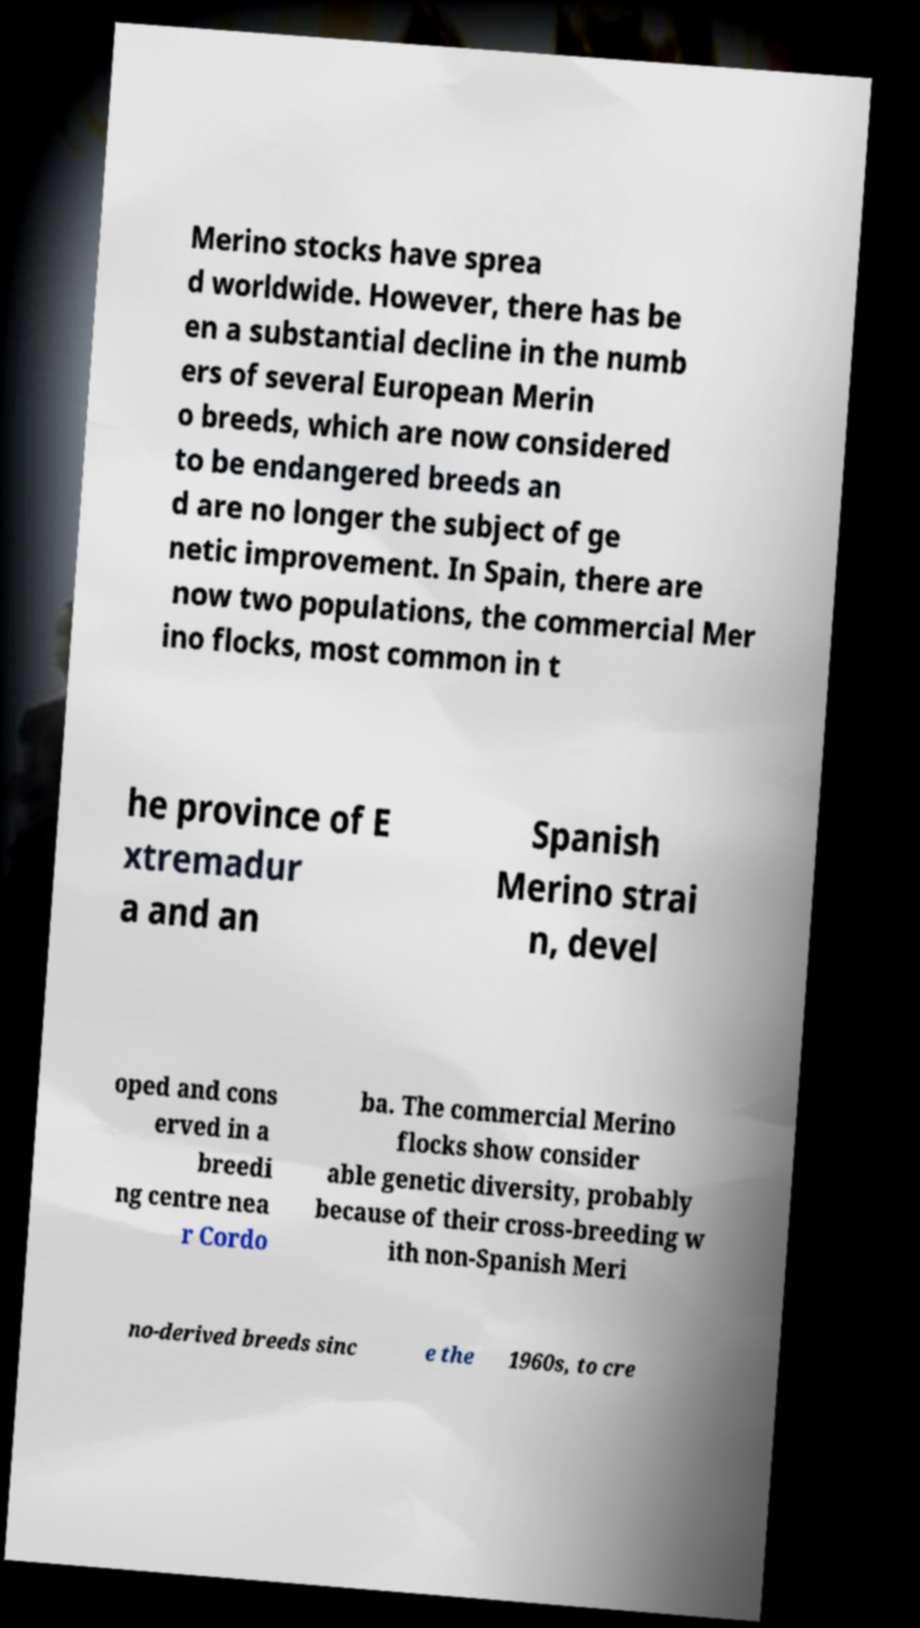Can you accurately transcribe the text from the provided image for me? Merino stocks have sprea d worldwide. However, there has be en a substantial decline in the numb ers of several European Merin o breeds, which are now considered to be endangered breeds an d are no longer the subject of ge netic improvement. In Spain, there are now two populations, the commercial Mer ino flocks, most common in t he province of E xtremadur a and an Spanish Merino strai n, devel oped and cons erved in a breedi ng centre nea r Cordo ba. The commercial Merino flocks show consider able genetic diversity, probably because of their cross-breeding w ith non-Spanish Meri no-derived breeds sinc e the 1960s, to cre 